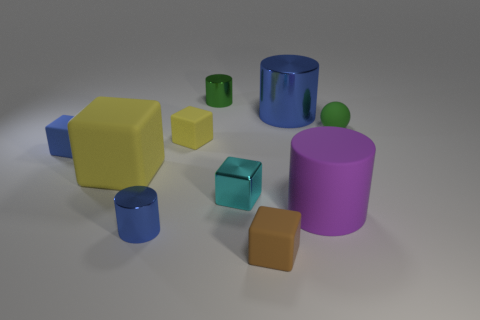Subtract all tiny brown matte blocks. How many blocks are left? 4 Subtract all cyan cubes. How many cubes are left? 4 Subtract all brown cylinders. Subtract all green cubes. How many cylinders are left? 4 Subtract all spheres. How many objects are left? 9 Add 3 small blue rubber things. How many small blue rubber things are left? 4 Add 6 tiny metal cylinders. How many tiny metal cylinders exist? 8 Subtract 0 gray blocks. How many objects are left? 10 Subtract all big purple metallic spheres. Subtract all cyan metallic cubes. How many objects are left? 9 